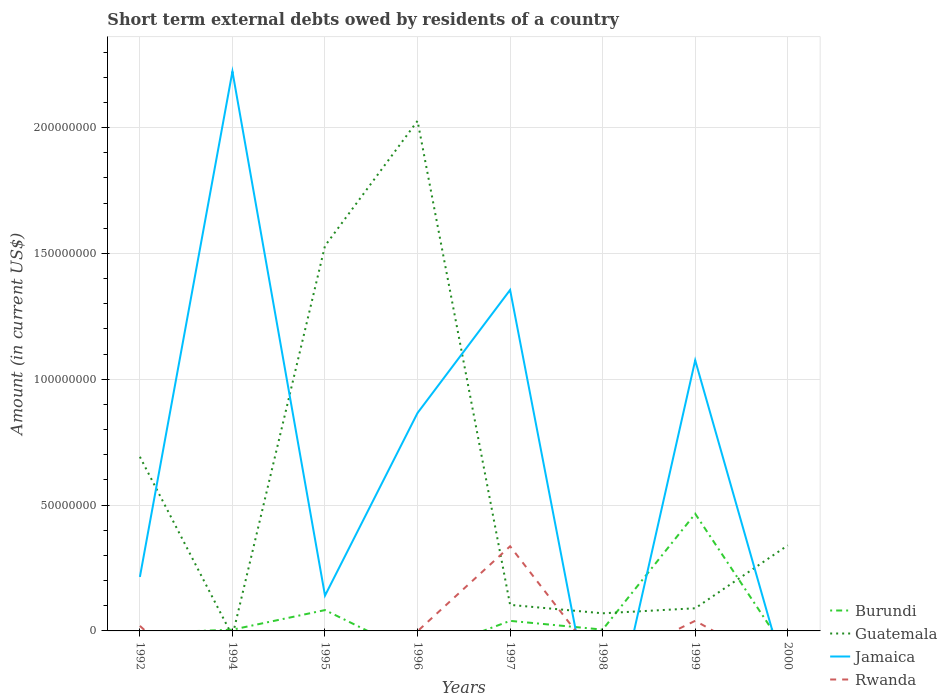Does the line corresponding to Jamaica intersect with the line corresponding to Rwanda?
Your answer should be compact. Yes. Is the number of lines equal to the number of legend labels?
Ensure brevity in your answer.  No. Across all years, what is the maximum amount of short-term external debts owed by residents in Guatemala?
Provide a short and direct response. 0. What is the total amount of short-term external debts owed by residents in Burundi in the graph?
Your answer should be compact. -4.61e+07. What is the difference between the highest and the second highest amount of short-term external debts owed by residents in Rwanda?
Make the answer very short. 3.36e+07. How many lines are there?
Your answer should be very brief. 4. Are the values on the major ticks of Y-axis written in scientific E-notation?
Ensure brevity in your answer.  No. Does the graph contain grids?
Your answer should be compact. Yes. Where does the legend appear in the graph?
Provide a short and direct response. Bottom right. How many legend labels are there?
Offer a very short reply. 4. How are the legend labels stacked?
Offer a very short reply. Vertical. What is the title of the graph?
Give a very brief answer. Short term external debts owed by residents of a country. Does "Venezuela" appear as one of the legend labels in the graph?
Your answer should be very brief. No. What is the Amount (in current US$) of Guatemala in 1992?
Your answer should be compact. 6.92e+07. What is the Amount (in current US$) of Jamaica in 1992?
Your response must be concise. 2.14e+07. What is the Amount (in current US$) of Rwanda in 1992?
Provide a short and direct response. 2.00e+06. What is the Amount (in current US$) of Burundi in 1994?
Ensure brevity in your answer.  4.90e+05. What is the Amount (in current US$) in Guatemala in 1994?
Your answer should be compact. 0. What is the Amount (in current US$) of Jamaica in 1994?
Provide a short and direct response. 2.22e+08. What is the Amount (in current US$) in Rwanda in 1994?
Make the answer very short. 0. What is the Amount (in current US$) in Burundi in 1995?
Provide a short and direct response. 8.28e+06. What is the Amount (in current US$) in Guatemala in 1995?
Keep it short and to the point. 1.53e+08. What is the Amount (in current US$) in Jamaica in 1995?
Give a very brief answer. 1.40e+07. What is the Amount (in current US$) of Guatemala in 1996?
Your answer should be very brief. 2.03e+08. What is the Amount (in current US$) of Jamaica in 1996?
Make the answer very short. 8.66e+07. What is the Amount (in current US$) of Rwanda in 1996?
Your response must be concise. 0. What is the Amount (in current US$) of Guatemala in 1997?
Give a very brief answer. 1.04e+07. What is the Amount (in current US$) in Jamaica in 1997?
Your response must be concise. 1.35e+08. What is the Amount (in current US$) of Rwanda in 1997?
Offer a very short reply. 3.36e+07. What is the Amount (in current US$) of Burundi in 1998?
Provide a succinct answer. 5.20e+05. What is the Amount (in current US$) in Guatemala in 1998?
Ensure brevity in your answer.  7.00e+06. What is the Amount (in current US$) of Burundi in 1999?
Give a very brief answer. 4.66e+07. What is the Amount (in current US$) of Guatemala in 1999?
Provide a succinct answer. 9.00e+06. What is the Amount (in current US$) in Jamaica in 1999?
Give a very brief answer. 1.08e+08. What is the Amount (in current US$) in Rwanda in 1999?
Make the answer very short. 4.02e+06. What is the Amount (in current US$) in Burundi in 2000?
Your answer should be compact. 0. What is the Amount (in current US$) in Guatemala in 2000?
Your response must be concise. 3.40e+07. What is the Amount (in current US$) in Rwanda in 2000?
Ensure brevity in your answer.  0. Across all years, what is the maximum Amount (in current US$) of Burundi?
Your answer should be compact. 4.66e+07. Across all years, what is the maximum Amount (in current US$) in Guatemala?
Ensure brevity in your answer.  2.03e+08. Across all years, what is the maximum Amount (in current US$) in Jamaica?
Your response must be concise. 2.22e+08. Across all years, what is the maximum Amount (in current US$) in Rwanda?
Your response must be concise. 3.36e+07. Across all years, what is the minimum Amount (in current US$) of Guatemala?
Offer a very short reply. 0. Across all years, what is the minimum Amount (in current US$) of Jamaica?
Your answer should be very brief. 0. What is the total Amount (in current US$) in Burundi in the graph?
Your response must be concise. 5.98e+07. What is the total Amount (in current US$) in Guatemala in the graph?
Offer a terse response. 4.85e+08. What is the total Amount (in current US$) of Jamaica in the graph?
Your answer should be very brief. 5.87e+08. What is the total Amount (in current US$) of Rwanda in the graph?
Your response must be concise. 3.96e+07. What is the difference between the Amount (in current US$) in Jamaica in 1992 and that in 1994?
Your answer should be compact. -2.01e+08. What is the difference between the Amount (in current US$) of Guatemala in 1992 and that in 1995?
Your response must be concise. -8.38e+07. What is the difference between the Amount (in current US$) in Jamaica in 1992 and that in 1995?
Offer a very short reply. 7.42e+06. What is the difference between the Amount (in current US$) in Guatemala in 1992 and that in 1996?
Provide a short and direct response. -1.33e+08. What is the difference between the Amount (in current US$) in Jamaica in 1992 and that in 1996?
Keep it short and to the point. -6.52e+07. What is the difference between the Amount (in current US$) in Guatemala in 1992 and that in 1997?
Your answer should be compact. 5.88e+07. What is the difference between the Amount (in current US$) in Jamaica in 1992 and that in 1997?
Offer a very short reply. -1.14e+08. What is the difference between the Amount (in current US$) of Rwanda in 1992 and that in 1997?
Offer a terse response. -3.16e+07. What is the difference between the Amount (in current US$) in Guatemala in 1992 and that in 1998?
Provide a succinct answer. 6.22e+07. What is the difference between the Amount (in current US$) of Guatemala in 1992 and that in 1999?
Ensure brevity in your answer.  6.02e+07. What is the difference between the Amount (in current US$) of Jamaica in 1992 and that in 1999?
Offer a very short reply. -8.61e+07. What is the difference between the Amount (in current US$) in Rwanda in 1992 and that in 1999?
Provide a succinct answer. -2.02e+06. What is the difference between the Amount (in current US$) in Guatemala in 1992 and that in 2000?
Provide a short and direct response. 3.52e+07. What is the difference between the Amount (in current US$) in Burundi in 1994 and that in 1995?
Give a very brief answer. -7.79e+06. What is the difference between the Amount (in current US$) in Jamaica in 1994 and that in 1995?
Your answer should be very brief. 2.08e+08. What is the difference between the Amount (in current US$) of Jamaica in 1994 and that in 1996?
Ensure brevity in your answer.  1.36e+08. What is the difference between the Amount (in current US$) of Burundi in 1994 and that in 1997?
Give a very brief answer. -3.51e+06. What is the difference between the Amount (in current US$) in Jamaica in 1994 and that in 1997?
Your answer should be compact. 8.68e+07. What is the difference between the Amount (in current US$) in Burundi in 1994 and that in 1999?
Offer a very short reply. -4.61e+07. What is the difference between the Amount (in current US$) of Jamaica in 1994 and that in 1999?
Offer a very short reply. 1.15e+08. What is the difference between the Amount (in current US$) in Guatemala in 1995 and that in 1996?
Give a very brief answer. -4.96e+07. What is the difference between the Amount (in current US$) of Jamaica in 1995 and that in 1996?
Your answer should be very brief. -7.26e+07. What is the difference between the Amount (in current US$) of Burundi in 1995 and that in 1997?
Your answer should be very brief. 4.28e+06. What is the difference between the Amount (in current US$) in Guatemala in 1995 and that in 1997?
Provide a short and direct response. 1.43e+08. What is the difference between the Amount (in current US$) in Jamaica in 1995 and that in 1997?
Offer a terse response. -1.21e+08. What is the difference between the Amount (in current US$) in Burundi in 1995 and that in 1998?
Keep it short and to the point. 7.76e+06. What is the difference between the Amount (in current US$) of Guatemala in 1995 and that in 1998?
Offer a terse response. 1.46e+08. What is the difference between the Amount (in current US$) in Burundi in 1995 and that in 1999?
Offer a terse response. -3.83e+07. What is the difference between the Amount (in current US$) of Guatemala in 1995 and that in 1999?
Offer a terse response. 1.44e+08. What is the difference between the Amount (in current US$) of Jamaica in 1995 and that in 1999?
Offer a terse response. -9.35e+07. What is the difference between the Amount (in current US$) of Guatemala in 1995 and that in 2000?
Your answer should be compact. 1.19e+08. What is the difference between the Amount (in current US$) in Guatemala in 1996 and that in 1997?
Keep it short and to the point. 1.92e+08. What is the difference between the Amount (in current US$) of Jamaica in 1996 and that in 1997?
Provide a short and direct response. -4.89e+07. What is the difference between the Amount (in current US$) of Guatemala in 1996 and that in 1998?
Provide a succinct answer. 1.96e+08. What is the difference between the Amount (in current US$) of Guatemala in 1996 and that in 1999?
Your answer should be very brief. 1.94e+08. What is the difference between the Amount (in current US$) in Jamaica in 1996 and that in 1999?
Provide a succinct answer. -2.09e+07. What is the difference between the Amount (in current US$) of Guatemala in 1996 and that in 2000?
Give a very brief answer. 1.69e+08. What is the difference between the Amount (in current US$) in Burundi in 1997 and that in 1998?
Give a very brief answer. 3.48e+06. What is the difference between the Amount (in current US$) in Guatemala in 1997 and that in 1998?
Provide a short and direct response. 3.35e+06. What is the difference between the Amount (in current US$) in Burundi in 1997 and that in 1999?
Provide a short and direct response. -4.26e+07. What is the difference between the Amount (in current US$) of Guatemala in 1997 and that in 1999?
Give a very brief answer. 1.35e+06. What is the difference between the Amount (in current US$) in Jamaica in 1997 and that in 1999?
Ensure brevity in your answer.  2.80e+07. What is the difference between the Amount (in current US$) in Rwanda in 1997 and that in 1999?
Your response must be concise. 2.96e+07. What is the difference between the Amount (in current US$) of Guatemala in 1997 and that in 2000?
Your answer should be compact. -2.36e+07. What is the difference between the Amount (in current US$) in Burundi in 1998 and that in 1999?
Offer a very short reply. -4.60e+07. What is the difference between the Amount (in current US$) in Guatemala in 1998 and that in 2000?
Make the answer very short. -2.70e+07. What is the difference between the Amount (in current US$) in Guatemala in 1999 and that in 2000?
Offer a terse response. -2.50e+07. What is the difference between the Amount (in current US$) in Guatemala in 1992 and the Amount (in current US$) in Jamaica in 1994?
Your answer should be very brief. -1.53e+08. What is the difference between the Amount (in current US$) in Guatemala in 1992 and the Amount (in current US$) in Jamaica in 1995?
Offer a terse response. 5.52e+07. What is the difference between the Amount (in current US$) in Guatemala in 1992 and the Amount (in current US$) in Jamaica in 1996?
Offer a very short reply. -1.74e+07. What is the difference between the Amount (in current US$) in Guatemala in 1992 and the Amount (in current US$) in Jamaica in 1997?
Your response must be concise. -6.63e+07. What is the difference between the Amount (in current US$) of Guatemala in 1992 and the Amount (in current US$) of Rwanda in 1997?
Your answer should be very brief. 3.56e+07. What is the difference between the Amount (in current US$) in Jamaica in 1992 and the Amount (in current US$) in Rwanda in 1997?
Provide a succinct answer. -1.22e+07. What is the difference between the Amount (in current US$) of Guatemala in 1992 and the Amount (in current US$) of Jamaica in 1999?
Give a very brief answer. -3.83e+07. What is the difference between the Amount (in current US$) of Guatemala in 1992 and the Amount (in current US$) of Rwanda in 1999?
Give a very brief answer. 6.52e+07. What is the difference between the Amount (in current US$) of Jamaica in 1992 and the Amount (in current US$) of Rwanda in 1999?
Give a very brief answer. 1.74e+07. What is the difference between the Amount (in current US$) in Burundi in 1994 and the Amount (in current US$) in Guatemala in 1995?
Make the answer very short. -1.53e+08. What is the difference between the Amount (in current US$) of Burundi in 1994 and the Amount (in current US$) of Jamaica in 1995?
Your answer should be compact. -1.35e+07. What is the difference between the Amount (in current US$) in Burundi in 1994 and the Amount (in current US$) in Guatemala in 1996?
Provide a succinct answer. -2.02e+08. What is the difference between the Amount (in current US$) of Burundi in 1994 and the Amount (in current US$) of Jamaica in 1996?
Make the answer very short. -8.61e+07. What is the difference between the Amount (in current US$) of Burundi in 1994 and the Amount (in current US$) of Guatemala in 1997?
Your answer should be very brief. -9.86e+06. What is the difference between the Amount (in current US$) of Burundi in 1994 and the Amount (in current US$) of Jamaica in 1997?
Offer a very short reply. -1.35e+08. What is the difference between the Amount (in current US$) in Burundi in 1994 and the Amount (in current US$) in Rwanda in 1997?
Provide a short and direct response. -3.31e+07. What is the difference between the Amount (in current US$) in Jamaica in 1994 and the Amount (in current US$) in Rwanda in 1997?
Keep it short and to the point. 1.89e+08. What is the difference between the Amount (in current US$) of Burundi in 1994 and the Amount (in current US$) of Guatemala in 1998?
Give a very brief answer. -6.51e+06. What is the difference between the Amount (in current US$) in Burundi in 1994 and the Amount (in current US$) in Guatemala in 1999?
Give a very brief answer. -8.51e+06. What is the difference between the Amount (in current US$) of Burundi in 1994 and the Amount (in current US$) of Jamaica in 1999?
Give a very brief answer. -1.07e+08. What is the difference between the Amount (in current US$) of Burundi in 1994 and the Amount (in current US$) of Rwanda in 1999?
Provide a succinct answer. -3.53e+06. What is the difference between the Amount (in current US$) in Jamaica in 1994 and the Amount (in current US$) in Rwanda in 1999?
Provide a succinct answer. 2.18e+08. What is the difference between the Amount (in current US$) of Burundi in 1994 and the Amount (in current US$) of Guatemala in 2000?
Your answer should be very brief. -3.35e+07. What is the difference between the Amount (in current US$) in Burundi in 1995 and the Amount (in current US$) in Guatemala in 1996?
Your answer should be compact. -1.94e+08. What is the difference between the Amount (in current US$) in Burundi in 1995 and the Amount (in current US$) in Jamaica in 1996?
Your answer should be compact. -7.83e+07. What is the difference between the Amount (in current US$) of Guatemala in 1995 and the Amount (in current US$) of Jamaica in 1996?
Make the answer very short. 6.64e+07. What is the difference between the Amount (in current US$) of Burundi in 1995 and the Amount (in current US$) of Guatemala in 1997?
Your answer should be very brief. -2.07e+06. What is the difference between the Amount (in current US$) of Burundi in 1995 and the Amount (in current US$) of Jamaica in 1997?
Your answer should be very brief. -1.27e+08. What is the difference between the Amount (in current US$) of Burundi in 1995 and the Amount (in current US$) of Rwanda in 1997?
Your response must be concise. -2.54e+07. What is the difference between the Amount (in current US$) of Guatemala in 1995 and the Amount (in current US$) of Jamaica in 1997?
Give a very brief answer. 1.75e+07. What is the difference between the Amount (in current US$) in Guatemala in 1995 and the Amount (in current US$) in Rwanda in 1997?
Keep it short and to the point. 1.19e+08. What is the difference between the Amount (in current US$) in Jamaica in 1995 and the Amount (in current US$) in Rwanda in 1997?
Provide a short and direct response. -1.96e+07. What is the difference between the Amount (in current US$) of Burundi in 1995 and the Amount (in current US$) of Guatemala in 1998?
Provide a succinct answer. 1.28e+06. What is the difference between the Amount (in current US$) of Burundi in 1995 and the Amount (in current US$) of Guatemala in 1999?
Your response must be concise. -7.20e+05. What is the difference between the Amount (in current US$) of Burundi in 1995 and the Amount (in current US$) of Jamaica in 1999?
Ensure brevity in your answer.  -9.92e+07. What is the difference between the Amount (in current US$) in Burundi in 1995 and the Amount (in current US$) in Rwanda in 1999?
Provide a short and direct response. 4.26e+06. What is the difference between the Amount (in current US$) in Guatemala in 1995 and the Amount (in current US$) in Jamaica in 1999?
Your response must be concise. 4.55e+07. What is the difference between the Amount (in current US$) in Guatemala in 1995 and the Amount (in current US$) in Rwanda in 1999?
Your answer should be very brief. 1.49e+08. What is the difference between the Amount (in current US$) of Jamaica in 1995 and the Amount (in current US$) of Rwanda in 1999?
Provide a short and direct response. 1.00e+07. What is the difference between the Amount (in current US$) in Burundi in 1995 and the Amount (in current US$) in Guatemala in 2000?
Give a very brief answer. -2.57e+07. What is the difference between the Amount (in current US$) of Guatemala in 1996 and the Amount (in current US$) of Jamaica in 1997?
Your answer should be very brief. 6.72e+07. What is the difference between the Amount (in current US$) of Guatemala in 1996 and the Amount (in current US$) of Rwanda in 1997?
Give a very brief answer. 1.69e+08. What is the difference between the Amount (in current US$) of Jamaica in 1996 and the Amount (in current US$) of Rwanda in 1997?
Your answer should be very brief. 5.30e+07. What is the difference between the Amount (in current US$) in Guatemala in 1996 and the Amount (in current US$) in Jamaica in 1999?
Make the answer very short. 9.51e+07. What is the difference between the Amount (in current US$) of Guatemala in 1996 and the Amount (in current US$) of Rwanda in 1999?
Your answer should be very brief. 1.99e+08. What is the difference between the Amount (in current US$) of Jamaica in 1996 and the Amount (in current US$) of Rwanda in 1999?
Ensure brevity in your answer.  8.26e+07. What is the difference between the Amount (in current US$) in Burundi in 1997 and the Amount (in current US$) in Guatemala in 1998?
Make the answer very short. -3.00e+06. What is the difference between the Amount (in current US$) of Burundi in 1997 and the Amount (in current US$) of Guatemala in 1999?
Provide a succinct answer. -5.00e+06. What is the difference between the Amount (in current US$) of Burundi in 1997 and the Amount (in current US$) of Jamaica in 1999?
Offer a terse response. -1.04e+08. What is the difference between the Amount (in current US$) in Burundi in 1997 and the Amount (in current US$) in Rwanda in 1999?
Provide a succinct answer. -2.00e+04. What is the difference between the Amount (in current US$) in Guatemala in 1997 and the Amount (in current US$) in Jamaica in 1999?
Offer a very short reply. -9.72e+07. What is the difference between the Amount (in current US$) in Guatemala in 1997 and the Amount (in current US$) in Rwanda in 1999?
Make the answer very short. 6.33e+06. What is the difference between the Amount (in current US$) in Jamaica in 1997 and the Amount (in current US$) in Rwanda in 1999?
Give a very brief answer. 1.31e+08. What is the difference between the Amount (in current US$) of Burundi in 1997 and the Amount (in current US$) of Guatemala in 2000?
Provide a short and direct response. -3.00e+07. What is the difference between the Amount (in current US$) of Burundi in 1998 and the Amount (in current US$) of Guatemala in 1999?
Your answer should be very brief. -8.48e+06. What is the difference between the Amount (in current US$) in Burundi in 1998 and the Amount (in current US$) in Jamaica in 1999?
Provide a succinct answer. -1.07e+08. What is the difference between the Amount (in current US$) of Burundi in 1998 and the Amount (in current US$) of Rwanda in 1999?
Provide a short and direct response. -3.50e+06. What is the difference between the Amount (in current US$) of Guatemala in 1998 and the Amount (in current US$) of Jamaica in 1999?
Make the answer very short. -1.01e+08. What is the difference between the Amount (in current US$) of Guatemala in 1998 and the Amount (in current US$) of Rwanda in 1999?
Your response must be concise. 2.98e+06. What is the difference between the Amount (in current US$) in Burundi in 1998 and the Amount (in current US$) in Guatemala in 2000?
Keep it short and to the point. -3.35e+07. What is the difference between the Amount (in current US$) of Burundi in 1999 and the Amount (in current US$) of Guatemala in 2000?
Make the answer very short. 1.26e+07. What is the average Amount (in current US$) of Burundi per year?
Offer a terse response. 7.48e+06. What is the average Amount (in current US$) in Guatemala per year?
Your answer should be very brief. 6.06e+07. What is the average Amount (in current US$) of Jamaica per year?
Offer a terse response. 7.34e+07. What is the average Amount (in current US$) in Rwanda per year?
Make the answer very short. 4.96e+06. In the year 1992, what is the difference between the Amount (in current US$) of Guatemala and Amount (in current US$) of Jamaica?
Ensure brevity in your answer.  4.77e+07. In the year 1992, what is the difference between the Amount (in current US$) of Guatemala and Amount (in current US$) of Rwanda?
Offer a very short reply. 6.72e+07. In the year 1992, what is the difference between the Amount (in current US$) in Jamaica and Amount (in current US$) in Rwanda?
Offer a very short reply. 1.94e+07. In the year 1994, what is the difference between the Amount (in current US$) of Burundi and Amount (in current US$) of Jamaica?
Provide a short and direct response. -2.22e+08. In the year 1995, what is the difference between the Amount (in current US$) in Burundi and Amount (in current US$) in Guatemala?
Offer a terse response. -1.45e+08. In the year 1995, what is the difference between the Amount (in current US$) of Burundi and Amount (in current US$) of Jamaica?
Give a very brief answer. -5.75e+06. In the year 1995, what is the difference between the Amount (in current US$) of Guatemala and Amount (in current US$) of Jamaica?
Ensure brevity in your answer.  1.39e+08. In the year 1996, what is the difference between the Amount (in current US$) in Guatemala and Amount (in current US$) in Jamaica?
Keep it short and to the point. 1.16e+08. In the year 1997, what is the difference between the Amount (in current US$) in Burundi and Amount (in current US$) in Guatemala?
Offer a very short reply. -6.35e+06. In the year 1997, what is the difference between the Amount (in current US$) in Burundi and Amount (in current US$) in Jamaica?
Offer a very short reply. -1.31e+08. In the year 1997, what is the difference between the Amount (in current US$) in Burundi and Amount (in current US$) in Rwanda?
Your answer should be very brief. -2.96e+07. In the year 1997, what is the difference between the Amount (in current US$) in Guatemala and Amount (in current US$) in Jamaica?
Offer a very short reply. -1.25e+08. In the year 1997, what is the difference between the Amount (in current US$) of Guatemala and Amount (in current US$) of Rwanda?
Offer a very short reply. -2.33e+07. In the year 1997, what is the difference between the Amount (in current US$) of Jamaica and Amount (in current US$) of Rwanda?
Keep it short and to the point. 1.02e+08. In the year 1998, what is the difference between the Amount (in current US$) in Burundi and Amount (in current US$) in Guatemala?
Give a very brief answer. -6.48e+06. In the year 1999, what is the difference between the Amount (in current US$) in Burundi and Amount (in current US$) in Guatemala?
Give a very brief answer. 3.76e+07. In the year 1999, what is the difference between the Amount (in current US$) of Burundi and Amount (in current US$) of Jamaica?
Keep it short and to the point. -6.10e+07. In the year 1999, what is the difference between the Amount (in current US$) in Burundi and Amount (in current US$) in Rwanda?
Make the answer very short. 4.25e+07. In the year 1999, what is the difference between the Amount (in current US$) of Guatemala and Amount (in current US$) of Jamaica?
Provide a succinct answer. -9.85e+07. In the year 1999, what is the difference between the Amount (in current US$) of Guatemala and Amount (in current US$) of Rwanda?
Your response must be concise. 4.98e+06. In the year 1999, what is the difference between the Amount (in current US$) in Jamaica and Amount (in current US$) in Rwanda?
Keep it short and to the point. 1.04e+08. What is the ratio of the Amount (in current US$) of Jamaica in 1992 to that in 1994?
Make the answer very short. 0.1. What is the ratio of the Amount (in current US$) of Guatemala in 1992 to that in 1995?
Your response must be concise. 0.45. What is the ratio of the Amount (in current US$) of Jamaica in 1992 to that in 1995?
Offer a terse response. 1.53. What is the ratio of the Amount (in current US$) in Guatemala in 1992 to that in 1996?
Make the answer very short. 0.34. What is the ratio of the Amount (in current US$) of Jamaica in 1992 to that in 1996?
Your answer should be compact. 0.25. What is the ratio of the Amount (in current US$) of Guatemala in 1992 to that in 1997?
Your answer should be compact. 6.68. What is the ratio of the Amount (in current US$) of Jamaica in 1992 to that in 1997?
Give a very brief answer. 0.16. What is the ratio of the Amount (in current US$) in Rwanda in 1992 to that in 1997?
Provide a succinct answer. 0.06. What is the ratio of the Amount (in current US$) of Guatemala in 1992 to that in 1998?
Offer a terse response. 9.88. What is the ratio of the Amount (in current US$) of Guatemala in 1992 to that in 1999?
Make the answer very short. 7.69. What is the ratio of the Amount (in current US$) in Jamaica in 1992 to that in 1999?
Keep it short and to the point. 0.2. What is the ratio of the Amount (in current US$) in Rwanda in 1992 to that in 1999?
Keep it short and to the point. 0.5. What is the ratio of the Amount (in current US$) in Guatemala in 1992 to that in 2000?
Your response must be concise. 2.03. What is the ratio of the Amount (in current US$) in Burundi in 1994 to that in 1995?
Make the answer very short. 0.06. What is the ratio of the Amount (in current US$) of Jamaica in 1994 to that in 1995?
Make the answer very short. 15.84. What is the ratio of the Amount (in current US$) of Jamaica in 1994 to that in 1996?
Your answer should be very brief. 2.57. What is the ratio of the Amount (in current US$) of Burundi in 1994 to that in 1997?
Ensure brevity in your answer.  0.12. What is the ratio of the Amount (in current US$) in Jamaica in 1994 to that in 1997?
Provide a succinct answer. 1.64. What is the ratio of the Amount (in current US$) of Burundi in 1994 to that in 1998?
Provide a short and direct response. 0.94. What is the ratio of the Amount (in current US$) in Burundi in 1994 to that in 1999?
Your response must be concise. 0.01. What is the ratio of the Amount (in current US$) in Jamaica in 1994 to that in 1999?
Give a very brief answer. 2.07. What is the ratio of the Amount (in current US$) of Guatemala in 1995 to that in 1996?
Provide a succinct answer. 0.76. What is the ratio of the Amount (in current US$) of Jamaica in 1995 to that in 1996?
Your answer should be very brief. 0.16. What is the ratio of the Amount (in current US$) of Burundi in 1995 to that in 1997?
Your response must be concise. 2.07. What is the ratio of the Amount (in current US$) in Guatemala in 1995 to that in 1997?
Provide a succinct answer. 14.78. What is the ratio of the Amount (in current US$) of Jamaica in 1995 to that in 1997?
Offer a terse response. 0.1. What is the ratio of the Amount (in current US$) in Burundi in 1995 to that in 1998?
Provide a short and direct response. 15.92. What is the ratio of the Amount (in current US$) of Guatemala in 1995 to that in 1998?
Your answer should be very brief. 21.86. What is the ratio of the Amount (in current US$) in Burundi in 1995 to that in 1999?
Provide a short and direct response. 0.18. What is the ratio of the Amount (in current US$) of Guatemala in 1995 to that in 1999?
Your answer should be compact. 17. What is the ratio of the Amount (in current US$) in Jamaica in 1995 to that in 1999?
Make the answer very short. 0.13. What is the ratio of the Amount (in current US$) in Guatemala in 1996 to that in 1997?
Ensure brevity in your answer.  19.58. What is the ratio of the Amount (in current US$) of Jamaica in 1996 to that in 1997?
Give a very brief answer. 0.64. What is the ratio of the Amount (in current US$) of Guatemala in 1996 to that in 1998?
Provide a short and direct response. 28.95. What is the ratio of the Amount (in current US$) of Guatemala in 1996 to that in 1999?
Offer a very short reply. 22.52. What is the ratio of the Amount (in current US$) of Jamaica in 1996 to that in 1999?
Offer a terse response. 0.81. What is the ratio of the Amount (in current US$) of Guatemala in 1996 to that in 2000?
Offer a terse response. 5.96. What is the ratio of the Amount (in current US$) in Burundi in 1997 to that in 1998?
Ensure brevity in your answer.  7.69. What is the ratio of the Amount (in current US$) of Guatemala in 1997 to that in 1998?
Ensure brevity in your answer.  1.48. What is the ratio of the Amount (in current US$) of Burundi in 1997 to that in 1999?
Make the answer very short. 0.09. What is the ratio of the Amount (in current US$) of Guatemala in 1997 to that in 1999?
Your answer should be very brief. 1.15. What is the ratio of the Amount (in current US$) in Jamaica in 1997 to that in 1999?
Your response must be concise. 1.26. What is the ratio of the Amount (in current US$) of Rwanda in 1997 to that in 1999?
Provide a succinct answer. 8.37. What is the ratio of the Amount (in current US$) of Guatemala in 1997 to that in 2000?
Offer a very short reply. 0.3. What is the ratio of the Amount (in current US$) of Burundi in 1998 to that in 1999?
Your answer should be compact. 0.01. What is the ratio of the Amount (in current US$) of Guatemala in 1998 to that in 1999?
Your answer should be very brief. 0.78. What is the ratio of the Amount (in current US$) in Guatemala in 1998 to that in 2000?
Your answer should be very brief. 0.21. What is the ratio of the Amount (in current US$) of Guatemala in 1999 to that in 2000?
Keep it short and to the point. 0.26. What is the difference between the highest and the second highest Amount (in current US$) of Burundi?
Provide a short and direct response. 3.83e+07. What is the difference between the highest and the second highest Amount (in current US$) of Guatemala?
Ensure brevity in your answer.  4.96e+07. What is the difference between the highest and the second highest Amount (in current US$) in Jamaica?
Your answer should be compact. 8.68e+07. What is the difference between the highest and the second highest Amount (in current US$) in Rwanda?
Provide a succinct answer. 2.96e+07. What is the difference between the highest and the lowest Amount (in current US$) in Burundi?
Make the answer very short. 4.66e+07. What is the difference between the highest and the lowest Amount (in current US$) in Guatemala?
Offer a very short reply. 2.03e+08. What is the difference between the highest and the lowest Amount (in current US$) in Jamaica?
Your answer should be very brief. 2.22e+08. What is the difference between the highest and the lowest Amount (in current US$) in Rwanda?
Your answer should be very brief. 3.36e+07. 